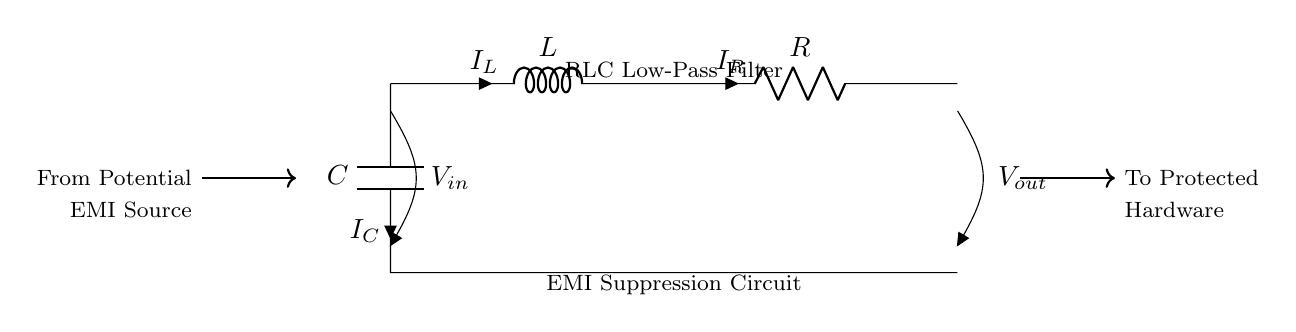What components are present in the circuit? The components visible in the diagram are a resistor, inductor, and capacitor. This can be directly seen from the labels next to the circuit elements, R for resistor, L for inductor, and C for capacitor.
Answer: resistor, inductor, capacitor What is the purpose of the circuit? The circuit is identified as an EMI Suppression Circuit and is designed as a low-pass filter. This designation indicates that its primary purpose is to suppress electromagnetic interference by allowing lower frequency signals to pass while attenuating higher frequencies.
Answer: EMI Suppression Circuit What is the direction of current through the inductor? The current through the inductor is indicated by the arrow marked I_L. This arrow points upwards, indicating that the current is flowing from the bottom of the inductor towards the top, which is an essential characteristic to understand the behavior of the inductor in the circuit.
Answer: upwards What is the voltage across the capacitor? The voltage across the capacitor is labeled as V_in, showing that it is linked directly to the input voltage at the top. This indicates that the voltage across the capacitor is the same as the input voltage provided to the circuit, which is a fundamental element in analyzing filter circuits.
Answer: V_in Explain how the components interact to suppress EMI. The inductor resists changes in current, the capacitor blocks high-frequency signals, and the resistor provides a path for current. Together, this series connection allows lower frequency signals to pass while filtering out higher frequencies associated with EMI interference. The inductor and capacitor create a resonant circuit that diminishes unwanted EMI, thereby ensuring the integrity of the signals being processed in nearby hardware.
Answer: RLC filter interaction What is V_out in relation to V_in? V_out is the output voltage taken after the resistor in this circuit. Since this is a low-pass filter design, V_out will be lower than V_in when high-frequency noise is present, reflecting the filtering characteristic of the circuit. The current through the components determines how much of the input voltage is output as a clean signal.
Answer: lower than V_in 